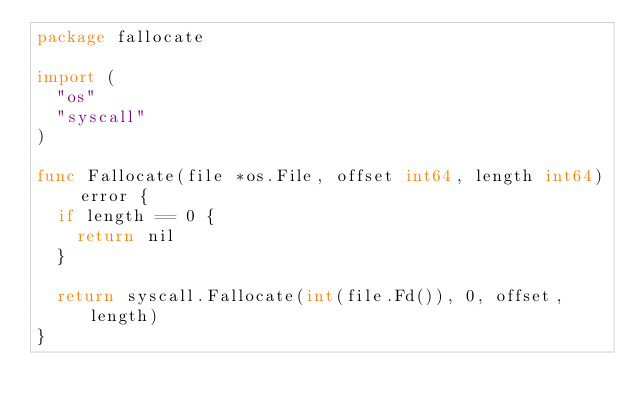Convert code to text. <code><loc_0><loc_0><loc_500><loc_500><_Go_>package fallocate

import (
	"os"
	"syscall"
)

func Fallocate(file *os.File, offset int64, length int64) error {
	if length == 0 {
		return nil
	}

	return syscall.Fallocate(int(file.Fd()), 0, offset, length)
}
</code> 